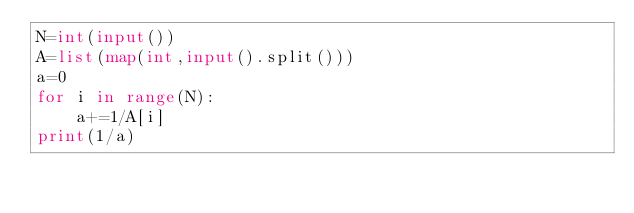<code> <loc_0><loc_0><loc_500><loc_500><_Python_>N=int(input())
A=list(map(int,input().split()))
a=0
for i in range(N):
    a+=1/A[i]
print(1/a)</code> 